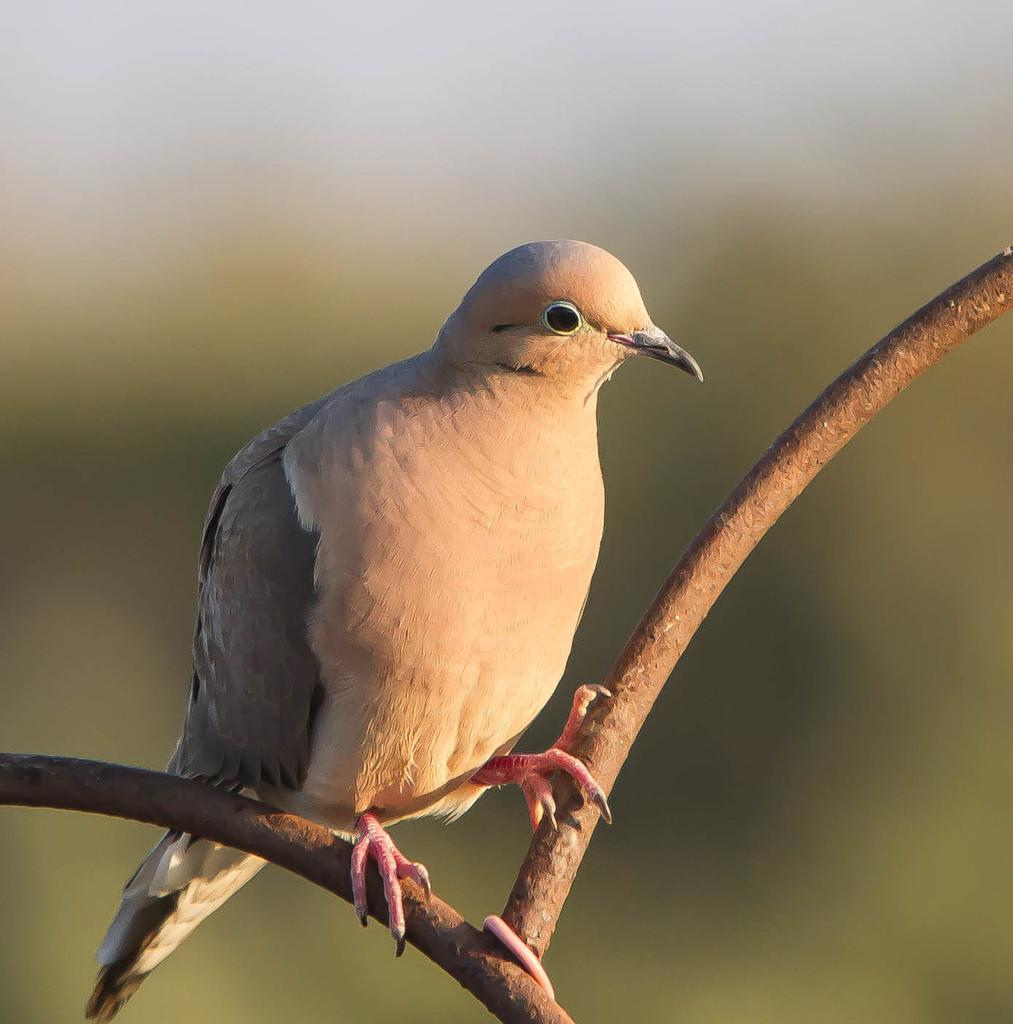What type of animal is in the image? There is a bird in the image. Where is the bird located? The bird is standing on a branch. What color is the background behind the bird? The background of the bird is blue. How many men are holding a finger in the image? There are no men or fingers present in the image; it features a bird standing on a branch with a blue background. 